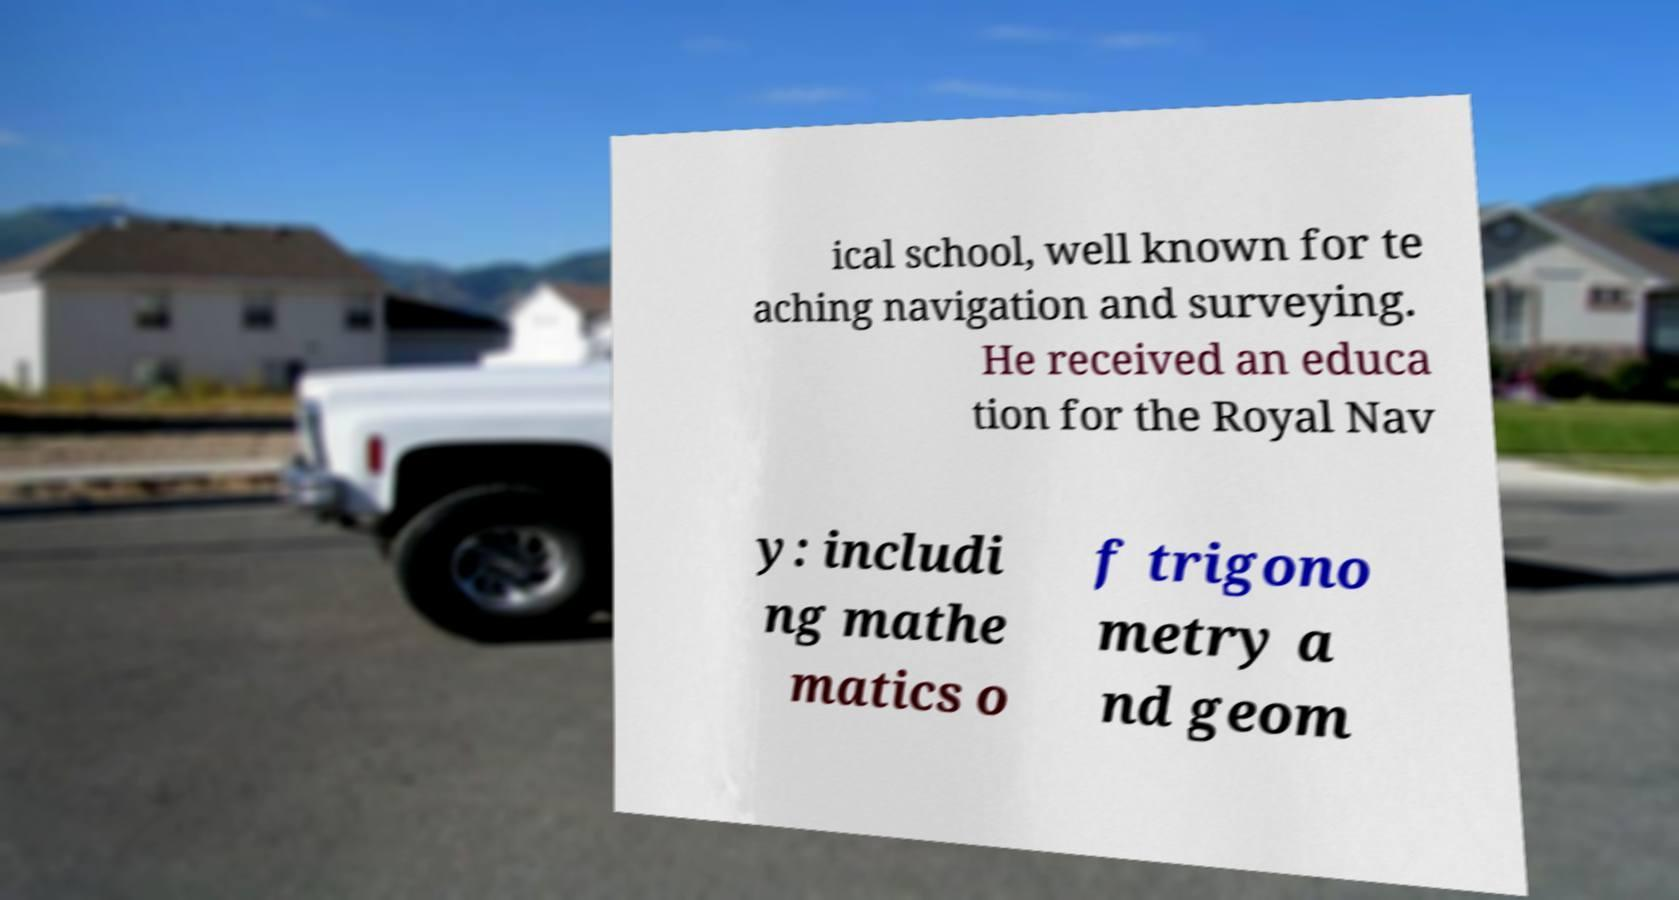For documentation purposes, I need the text within this image transcribed. Could you provide that? ical school, well known for te aching navigation and surveying. He received an educa tion for the Royal Nav y: includi ng mathe matics o f trigono metry a nd geom 